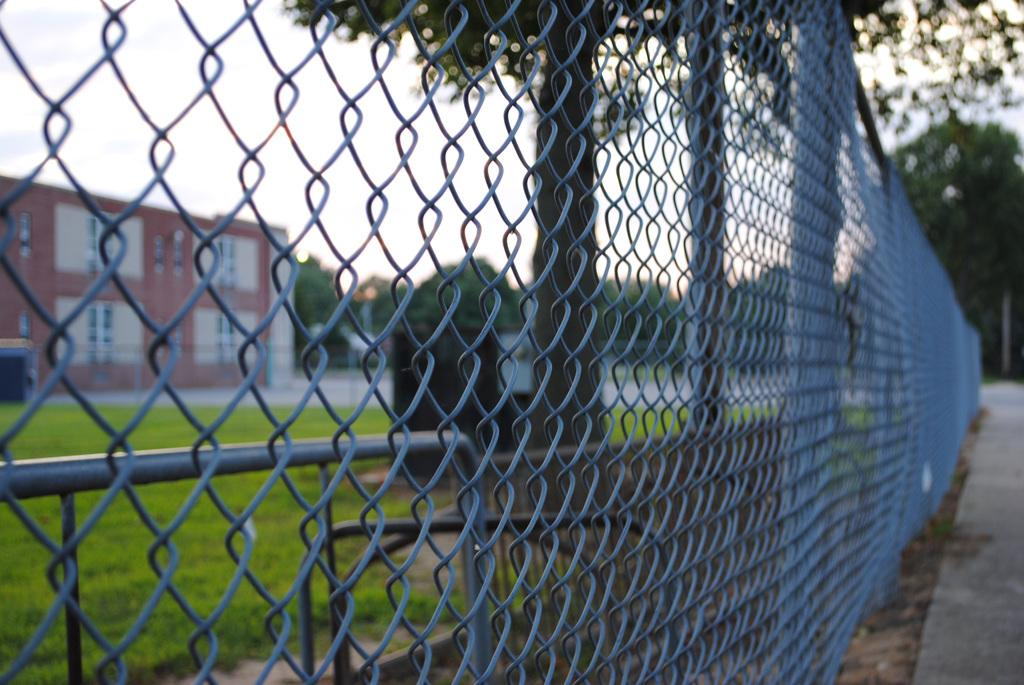What structure is located on the left side of the image? There is a building on the left side of the image. What type of barrier is present in the image? There is a metal fence in the image. What can be seen in the background of the image? There are trees in the background of the image. How would you describe the sky in the image? The sky is cloudy in the image. What type of vegetation is on the ground in the image? There is grass on the ground in the image. What type of nose can be seen on the building in the image? There is no nose present on the building in the image. What discovery was made by the person who took the image? The facts provided do not give any information about a discovery made by the person who took the image. 